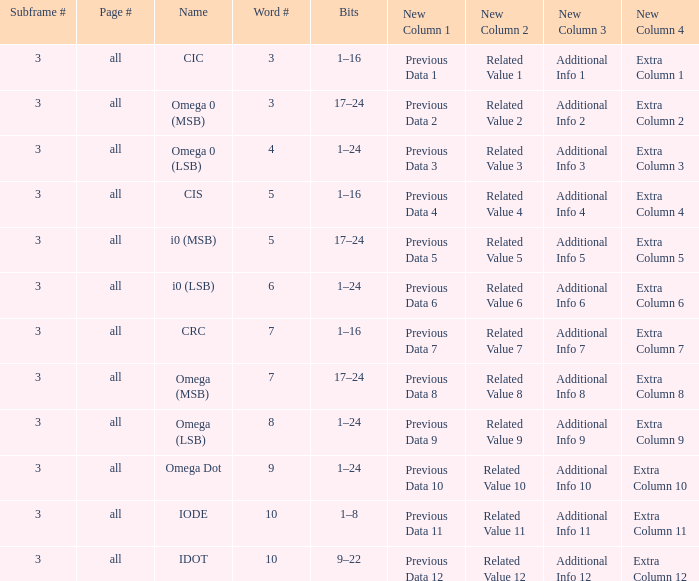What is the total word count with a subframe count greater than 3? None. 